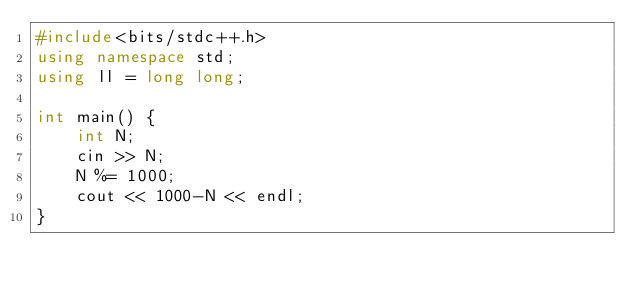<code> <loc_0><loc_0><loc_500><loc_500><_C++_>#include<bits/stdc++.h>
using namespace std;
using ll = long long;

int main() {
    int N;
    cin >> N;
    N %= 1000;
    cout << 1000-N << endl;
}</code> 